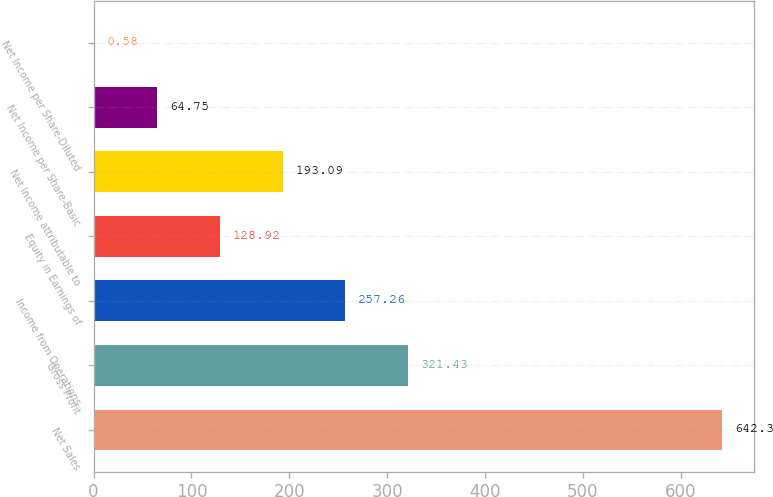Convert chart to OTSL. <chart><loc_0><loc_0><loc_500><loc_500><bar_chart><fcel>Net Sales<fcel>Gross Profit<fcel>Income from Operations<fcel>Equity in Earnings of<fcel>Net Income attributable to<fcel>Net Income per Share-Basic<fcel>Net Income per Share-Diluted<nl><fcel>642.3<fcel>321.43<fcel>257.26<fcel>128.92<fcel>193.09<fcel>64.75<fcel>0.58<nl></chart> 